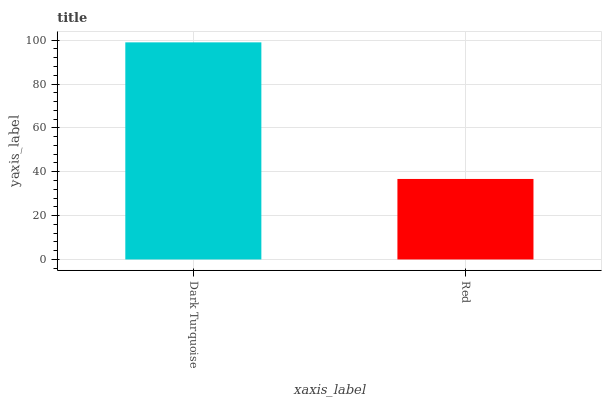Is Red the minimum?
Answer yes or no. Yes. Is Dark Turquoise the maximum?
Answer yes or no. Yes. Is Red the maximum?
Answer yes or no. No. Is Dark Turquoise greater than Red?
Answer yes or no. Yes. Is Red less than Dark Turquoise?
Answer yes or no. Yes. Is Red greater than Dark Turquoise?
Answer yes or no. No. Is Dark Turquoise less than Red?
Answer yes or no. No. Is Dark Turquoise the high median?
Answer yes or no. Yes. Is Red the low median?
Answer yes or no. Yes. Is Red the high median?
Answer yes or no. No. Is Dark Turquoise the low median?
Answer yes or no. No. 